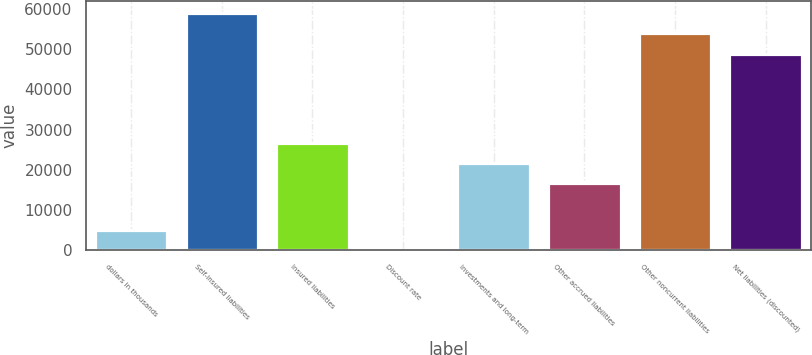Convert chart to OTSL. <chart><loc_0><loc_0><loc_500><loc_500><bar_chart><fcel>dollars in thousands<fcel>Self-insured liabilities<fcel>Insured liabilities<fcel>Discount rate<fcel>Investments and long-term<fcel>Other accrued liabilities<fcel>Other noncurrent liabilities<fcel>Net liabilities (discounted)<nl><fcel>5054.68<fcel>58995.4<fcel>26764.4<fcel>0.98<fcel>21710.7<fcel>16657<fcel>53941.7<fcel>48888<nl></chart> 